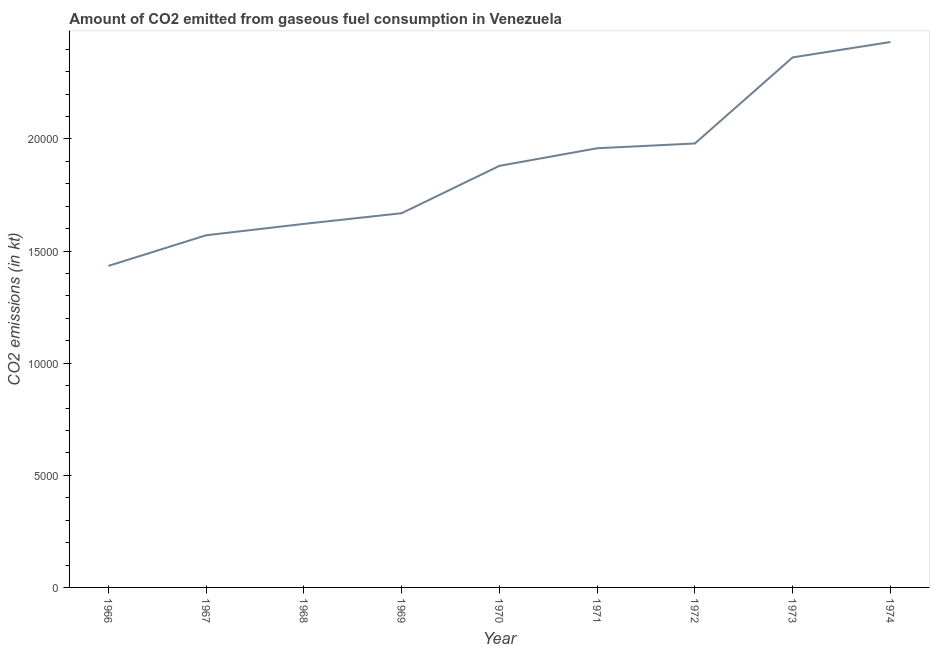What is the co2 emissions from gaseous fuel consumption in 1969?
Your answer should be compact. 1.67e+04. Across all years, what is the maximum co2 emissions from gaseous fuel consumption?
Ensure brevity in your answer.  2.43e+04. Across all years, what is the minimum co2 emissions from gaseous fuel consumption?
Your answer should be very brief. 1.43e+04. In which year was the co2 emissions from gaseous fuel consumption maximum?
Give a very brief answer. 1974. In which year was the co2 emissions from gaseous fuel consumption minimum?
Provide a short and direct response. 1966. What is the sum of the co2 emissions from gaseous fuel consumption?
Make the answer very short. 1.69e+05. What is the difference between the co2 emissions from gaseous fuel consumption in 1970 and 1971?
Keep it short and to the point. -784.74. What is the average co2 emissions from gaseous fuel consumption per year?
Your answer should be compact. 1.88e+04. What is the median co2 emissions from gaseous fuel consumption?
Ensure brevity in your answer.  1.88e+04. What is the ratio of the co2 emissions from gaseous fuel consumption in 1972 to that in 1974?
Ensure brevity in your answer.  0.81. Is the co2 emissions from gaseous fuel consumption in 1973 less than that in 1974?
Ensure brevity in your answer.  Yes. Is the difference between the co2 emissions from gaseous fuel consumption in 1971 and 1974 greater than the difference between any two years?
Keep it short and to the point. No. What is the difference between the highest and the second highest co2 emissions from gaseous fuel consumption?
Offer a very short reply. 685.73. Is the sum of the co2 emissions from gaseous fuel consumption in 1969 and 1972 greater than the maximum co2 emissions from gaseous fuel consumption across all years?
Your response must be concise. Yes. What is the difference between the highest and the lowest co2 emissions from gaseous fuel consumption?
Make the answer very short. 9985.24. In how many years, is the co2 emissions from gaseous fuel consumption greater than the average co2 emissions from gaseous fuel consumption taken over all years?
Ensure brevity in your answer.  5. Does the graph contain grids?
Your answer should be very brief. No. What is the title of the graph?
Your answer should be compact. Amount of CO2 emitted from gaseous fuel consumption in Venezuela. What is the label or title of the Y-axis?
Your answer should be compact. CO2 emissions (in kt). What is the CO2 emissions (in kt) of 1966?
Keep it short and to the point. 1.43e+04. What is the CO2 emissions (in kt) in 1967?
Offer a very short reply. 1.57e+04. What is the CO2 emissions (in kt) in 1968?
Offer a very short reply. 1.62e+04. What is the CO2 emissions (in kt) in 1969?
Your answer should be compact. 1.67e+04. What is the CO2 emissions (in kt) of 1970?
Provide a succinct answer. 1.88e+04. What is the CO2 emissions (in kt) of 1971?
Make the answer very short. 1.96e+04. What is the CO2 emissions (in kt) in 1972?
Give a very brief answer. 1.98e+04. What is the CO2 emissions (in kt) of 1973?
Give a very brief answer. 2.36e+04. What is the CO2 emissions (in kt) in 1974?
Your answer should be compact. 2.43e+04. What is the difference between the CO2 emissions (in kt) in 1966 and 1967?
Give a very brief answer. -1367.79. What is the difference between the CO2 emissions (in kt) in 1966 and 1968?
Your response must be concise. -1873.84. What is the difference between the CO2 emissions (in kt) in 1966 and 1969?
Offer a terse response. -2350.55. What is the difference between the CO2 emissions (in kt) in 1966 and 1970?
Keep it short and to the point. -4462.74. What is the difference between the CO2 emissions (in kt) in 1966 and 1971?
Make the answer very short. -5247.48. What is the difference between the CO2 emissions (in kt) in 1966 and 1972?
Give a very brief answer. -5460.16. What is the difference between the CO2 emissions (in kt) in 1966 and 1973?
Offer a very short reply. -9299.51. What is the difference between the CO2 emissions (in kt) in 1966 and 1974?
Provide a succinct answer. -9985.24. What is the difference between the CO2 emissions (in kt) in 1967 and 1968?
Make the answer very short. -506.05. What is the difference between the CO2 emissions (in kt) in 1967 and 1969?
Provide a short and direct response. -982.76. What is the difference between the CO2 emissions (in kt) in 1967 and 1970?
Your answer should be compact. -3094.95. What is the difference between the CO2 emissions (in kt) in 1967 and 1971?
Your answer should be compact. -3879.69. What is the difference between the CO2 emissions (in kt) in 1967 and 1972?
Offer a very short reply. -4092.37. What is the difference between the CO2 emissions (in kt) in 1967 and 1973?
Your answer should be compact. -7931.72. What is the difference between the CO2 emissions (in kt) in 1967 and 1974?
Your answer should be very brief. -8617.45. What is the difference between the CO2 emissions (in kt) in 1968 and 1969?
Provide a succinct answer. -476.71. What is the difference between the CO2 emissions (in kt) in 1968 and 1970?
Offer a very short reply. -2588.9. What is the difference between the CO2 emissions (in kt) in 1968 and 1971?
Provide a succinct answer. -3373.64. What is the difference between the CO2 emissions (in kt) in 1968 and 1972?
Make the answer very short. -3586.33. What is the difference between the CO2 emissions (in kt) in 1968 and 1973?
Provide a short and direct response. -7425.68. What is the difference between the CO2 emissions (in kt) in 1968 and 1974?
Your answer should be compact. -8111.4. What is the difference between the CO2 emissions (in kt) in 1969 and 1970?
Give a very brief answer. -2112.19. What is the difference between the CO2 emissions (in kt) in 1969 and 1971?
Offer a terse response. -2896.93. What is the difference between the CO2 emissions (in kt) in 1969 and 1972?
Offer a very short reply. -3109.62. What is the difference between the CO2 emissions (in kt) in 1969 and 1973?
Offer a terse response. -6948.97. What is the difference between the CO2 emissions (in kt) in 1969 and 1974?
Your response must be concise. -7634.69. What is the difference between the CO2 emissions (in kt) in 1970 and 1971?
Keep it short and to the point. -784.74. What is the difference between the CO2 emissions (in kt) in 1970 and 1972?
Give a very brief answer. -997.42. What is the difference between the CO2 emissions (in kt) in 1970 and 1973?
Give a very brief answer. -4836.77. What is the difference between the CO2 emissions (in kt) in 1970 and 1974?
Provide a succinct answer. -5522.5. What is the difference between the CO2 emissions (in kt) in 1971 and 1972?
Make the answer very short. -212.69. What is the difference between the CO2 emissions (in kt) in 1971 and 1973?
Provide a short and direct response. -4052.03. What is the difference between the CO2 emissions (in kt) in 1971 and 1974?
Provide a succinct answer. -4737.76. What is the difference between the CO2 emissions (in kt) in 1972 and 1973?
Offer a very short reply. -3839.35. What is the difference between the CO2 emissions (in kt) in 1972 and 1974?
Offer a very short reply. -4525.08. What is the difference between the CO2 emissions (in kt) in 1973 and 1974?
Keep it short and to the point. -685.73. What is the ratio of the CO2 emissions (in kt) in 1966 to that in 1968?
Ensure brevity in your answer.  0.88. What is the ratio of the CO2 emissions (in kt) in 1966 to that in 1969?
Your answer should be very brief. 0.86. What is the ratio of the CO2 emissions (in kt) in 1966 to that in 1970?
Your response must be concise. 0.76. What is the ratio of the CO2 emissions (in kt) in 1966 to that in 1971?
Your response must be concise. 0.73. What is the ratio of the CO2 emissions (in kt) in 1966 to that in 1972?
Ensure brevity in your answer.  0.72. What is the ratio of the CO2 emissions (in kt) in 1966 to that in 1973?
Offer a very short reply. 0.61. What is the ratio of the CO2 emissions (in kt) in 1966 to that in 1974?
Give a very brief answer. 0.59. What is the ratio of the CO2 emissions (in kt) in 1967 to that in 1968?
Keep it short and to the point. 0.97. What is the ratio of the CO2 emissions (in kt) in 1967 to that in 1969?
Your response must be concise. 0.94. What is the ratio of the CO2 emissions (in kt) in 1967 to that in 1970?
Keep it short and to the point. 0.83. What is the ratio of the CO2 emissions (in kt) in 1967 to that in 1971?
Provide a short and direct response. 0.8. What is the ratio of the CO2 emissions (in kt) in 1967 to that in 1972?
Your response must be concise. 0.79. What is the ratio of the CO2 emissions (in kt) in 1967 to that in 1973?
Keep it short and to the point. 0.66. What is the ratio of the CO2 emissions (in kt) in 1967 to that in 1974?
Offer a very short reply. 0.65. What is the ratio of the CO2 emissions (in kt) in 1968 to that in 1969?
Make the answer very short. 0.97. What is the ratio of the CO2 emissions (in kt) in 1968 to that in 1970?
Keep it short and to the point. 0.86. What is the ratio of the CO2 emissions (in kt) in 1968 to that in 1971?
Offer a very short reply. 0.83. What is the ratio of the CO2 emissions (in kt) in 1968 to that in 1972?
Ensure brevity in your answer.  0.82. What is the ratio of the CO2 emissions (in kt) in 1968 to that in 1973?
Provide a short and direct response. 0.69. What is the ratio of the CO2 emissions (in kt) in 1968 to that in 1974?
Give a very brief answer. 0.67. What is the ratio of the CO2 emissions (in kt) in 1969 to that in 1970?
Keep it short and to the point. 0.89. What is the ratio of the CO2 emissions (in kt) in 1969 to that in 1971?
Offer a terse response. 0.85. What is the ratio of the CO2 emissions (in kt) in 1969 to that in 1972?
Provide a short and direct response. 0.84. What is the ratio of the CO2 emissions (in kt) in 1969 to that in 1973?
Your answer should be compact. 0.71. What is the ratio of the CO2 emissions (in kt) in 1969 to that in 1974?
Your answer should be very brief. 0.69. What is the ratio of the CO2 emissions (in kt) in 1970 to that in 1972?
Your answer should be compact. 0.95. What is the ratio of the CO2 emissions (in kt) in 1970 to that in 1973?
Give a very brief answer. 0.8. What is the ratio of the CO2 emissions (in kt) in 1970 to that in 1974?
Make the answer very short. 0.77. What is the ratio of the CO2 emissions (in kt) in 1971 to that in 1973?
Provide a succinct answer. 0.83. What is the ratio of the CO2 emissions (in kt) in 1971 to that in 1974?
Your answer should be very brief. 0.81. What is the ratio of the CO2 emissions (in kt) in 1972 to that in 1973?
Provide a succinct answer. 0.84. What is the ratio of the CO2 emissions (in kt) in 1972 to that in 1974?
Your answer should be very brief. 0.81. What is the ratio of the CO2 emissions (in kt) in 1973 to that in 1974?
Offer a terse response. 0.97. 